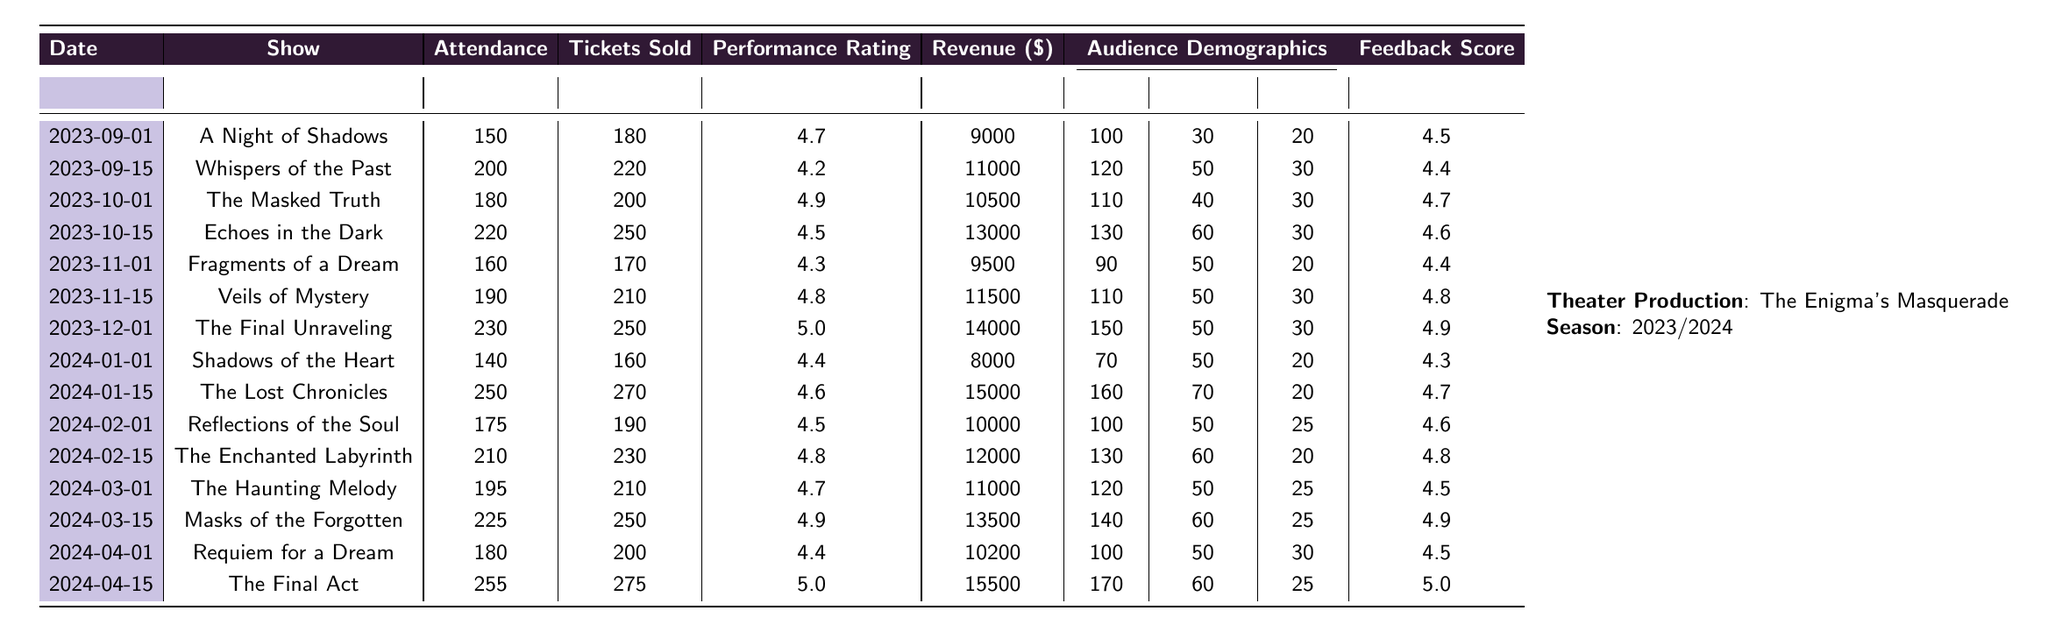What was the highest attendance for a show during the season? The highest attendance recorded is for "The Final Act" on April 15, 2024, with an attendance of 255.
Answer: 255 What is the total revenue generated by the production from all shows? Summing the revenue from each show gives: 9000 + 11000 + 10500 + 13000 + 9500 + 11500 + 14000 + 8000 + 15000 + 10000 + 12000 + 11000 + 13500 + 10200 + 15500 = 162700.
Answer: 162700 Which show had the highest performance rating? "The Final Unraveling" and "The Final Act" both received the highest performance rating of 5.0.
Answer: 5.0 How many more tickets were sold for "The Lost Chronicles" than for "Shadows of the Heart"? "The Lost Chronicles" sold 270 tickets while "Shadows of the Heart" sold 160 tickets; the difference is 270 - 160 = 110 tickets.
Answer: 110 Did "Veils of Mystery" have a higher attendance than "Fragments of a Dream"? Checking both entries, "Veils of Mystery" had an attendance of 190, while "Fragments of a Dream" had 160; therefore, it is true that "Veils of Mystery" had a higher attendance.
Answer: Yes What percentage of attendees for "Echoes in the Dark" were adults? The attendance for "Echoes in the Dark" was 220, and the number of adults was 130. The percentage of adults is (130 / 220) * 100 = 59.09%.
Answer: 59.09% What show had the lowest feedback score, and what was that score? "Shadows of the Heart" had the lowest feedback score of 4.3.
Answer: 4.3 How many seniors attended all shows combined during the season? Summing the number of seniors from each show gives: 20 + 30 + 30 + 30 + 20 + 30 + 30 + 20 + 20 + 25 + 20 + 25 + 30 + 25 = 380.
Answer: 380 What is the average performance rating across all shows? The performance ratings are: 4.7, 4.2, 4.9, 4.5, 4.3, 4.8, 5.0, 4.4, 4.6, 4.5, 4.8, 4.7, 4.9, 4.4, and 5.0. Summing these gives 67.0, and dividing by 15 (the number of shows) results in an average of 4.47.
Answer: 4.47 Did the attendance for "The Enchanted Labyrinth" exceed 200? "The Enchanted Labyrinth" had an attendance of 210, which exceeds 200. Hence, it is true.
Answer: Yes 